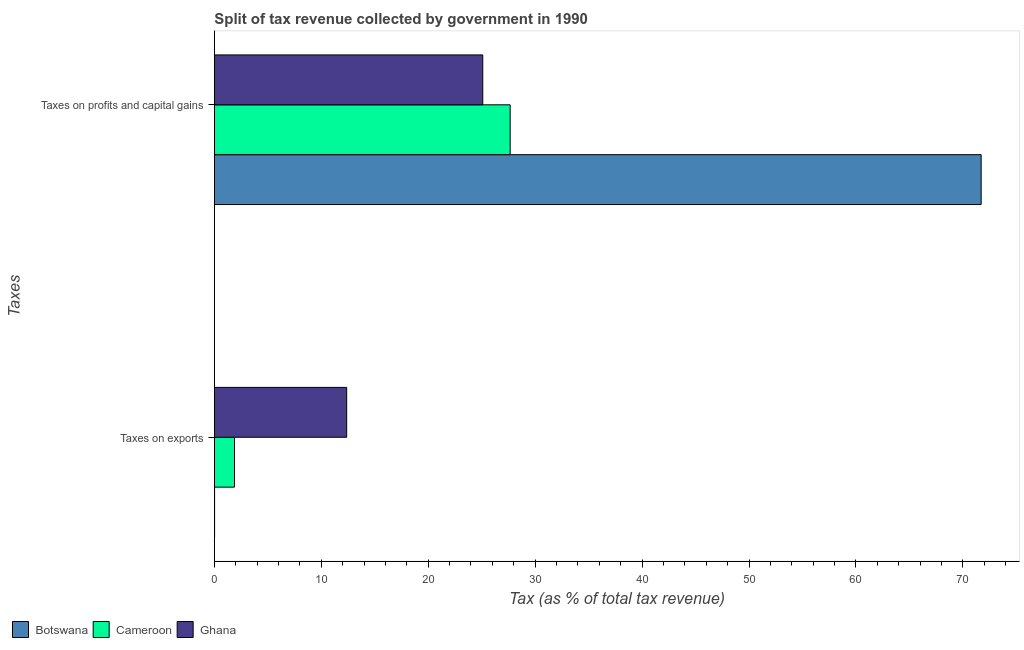Are the number of bars per tick equal to the number of legend labels?
Your answer should be very brief. Yes. Are the number of bars on each tick of the Y-axis equal?
Give a very brief answer. Yes. How many bars are there on the 1st tick from the top?
Keep it short and to the point. 3. How many bars are there on the 1st tick from the bottom?
Your response must be concise. 3. What is the label of the 2nd group of bars from the top?
Ensure brevity in your answer.  Taxes on exports. What is the percentage of revenue obtained from taxes on exports in Botswana?
Ensure brevity in your answer.  0.02. Across all countries, what is the maximum percentage of revenue obtained from taxes on profits and capital gains?
Provide a succinct answer. 71.71. Across all countries, what is the minimum percentage of revenue obtained from taxes on exports?
Provide a short and direct response. 0.02. In which country was the percentage of revenue obtained from taxes on exports maximum?
Give a very brief answer. Ghana. In which country was the percentage of revenue obtained from taxes on exports minimum?
Ensure brevity in your answer.  Botswana. What is the total percentage of revenue obtained from taxes on exports in the graph?
Your response must be concise. 14.28. What is the difference between the percentage of revenue obtained from taxes on exports in Ghana and that in Botswana?
Make the answer very short. 12.35. What is the difference between the percentage of revenue obtained from taxes on profits and capital gains in Ghana and the percentage of revenue obtained from taxes on exports in Botswana?
Your answer should be compact. 25.08. What is the average percentage of revenue obtained from taxes on exports per country?
Give a very brief answer. 4.76. What is the difference between the percentage of revenue obtained from taxes on exports and percentage of revenue obtained from taxes on profits and capital gains in Ghana?
Make the answer very short. -12.73. In how many countries, is the percentage of revenue obtained from taxes on exports greater than 66 %?
Provide a short and direct response. 0. What is the ratio of the percentage of revenue obtained from taxes on profits and capital gains in Cameroon to that in Botswana?
Offer a very short reply. 0.39. What does the 1st bar from the top in Taxes on exports represents?
Keep it short and to the point. Ghana. What does the 2nd bar from the bottom in Taxes on exports represents?
Give a very brief answer. Cameroon. How many bars are there?
Offer a terse response. 6. Are all the bars in the graph horizontal?
Give a very brief answer. Yes. How many countries are there in the graph?
Offer a very short reply. 3. Does the graph contain grids?
Make the answer very short. No. What is the title of the graph?
Offer a very short reply. Split of tax revenue collected by government in 1990. Does "Georgia" appear as one of the legend labels in the graph?
Your answer should be compact. No. What is the label or title of the X-axis?
Make the answer very short. Tax (as % of total tax revenue). What is the label or title of the Y-axis?
Provide a short and direct response. Taxes. What is the Tax (as % of total tax revenue) of Botswana in Taxes on exports?
Offer a very short reply. 0.02. What is the Tax (as % of total tax revenue) in Cameroon in Taxes on exports?
Keep it short and to the point. 1.89. What is the Tax (as % of total tax revenue) in Ghana in Taxes on exports?
Give a very brief answer. 12.37. What is the Tax (as % of total tax revenue) of Botswana in Taxes on profits and capital gains?
Offer a terse response. 71.71. What is the Tax (as % of total tax revenue) in Cameroon in Taxes on profits and capital gains?
Offer a very short reply. 27.66. What is the Tax (as % of total tax revenue) of Ghana in Taxes on profits and capital gains?
Offer a very short reply. 25.1. Across all Taxes, what is the maximum Tax (as % of total tax revenue) in Botswana?
Keep it short and to the point. 71.71. Across all Taxes, what is the maximum Tax (as % of total tax revenue) in Cameroon?
Offer a terse response. 27.66. Across all Taxes, what is the maximum Tax (as % of total tax revenue) of Ghana?
Your response must be concise. 25.1. Across all Taxes, what is the minimum Tax (as % of total tax revenue) in Botswana?
Make the answer very short. 0.02. Across all Taxes, what is the minimum Tax (as % of total tax revenue) of Cameroon?
Your response must be concise. 1.89. Across all Taxes, what is the minimum Tax (as % of total tax revenue) of Ghana?
Provide a short and direct response. 12.37. What is the total Tax (as % of total tax revenue) of Botswana in the graph?
Offer a terse response. 71.73. What is the total Tax (as % of total tax revenue) of Cameroon in the graph?
Provide a succinct answer. 29.55. What is the total Tax (as % of total tax revenue) in Ghana in the graph?
Make the answer very short. 37.48. What is the difference between the Tax (as % of total tax revenue) in Botswana in Taxes on exports and that in Taxes on profits and capital gains?
Make the answer very short. -71.69. What is the difference between the Tax (as % of total tax revenue) of Cameroon in Taxes on exports and that in Taxes on profits and capital gains?
Provide a short and direct response. -25.78. What is the difference between the Tax (as % of total tax revenue) in Ghana in Taxes on exports and that in Taxes on profits and capital gains?
Make the answer very short. -12.73. What is the difference between the Tax (as % of total tax revenue) of Botswana in Taxes on exports and the Tax (as % of total tax revenue) of Cameroon in Taxes on profits and capital gains?
Your response must be concise. -27.64. What is the difference between the Tax (as % of total tax revenue) in Botswana in Taxes on exports and the Tax (as % of total tax revenue) in Ghana in Taxes on profits and capital gains?
Your answer should be very brief. -25.08. What is the difference between the Tax (as % of total tax revenue) of Cameroon in Taxes on exports and the Tax (as % of total tax revenue) of Ghana in Taxes on profits and capital gains?
Your answer should be compact. -23.21. What is the average Tax (as % of total tax revenue) in Botswana per Taxes?
Provide a succinct answer. 35.87. What is the average Tax (as % of total tax revenue) of Cameroon per Taxes?
Provide a short and direct response. 14.77. What is the average Tax (as % of total tax revenue) of Ghana per Taxes?
Your answer should be very brief. 18.74. What is the difference between the Tax (as % of total tax revenue) in Botswana and Tax (as % of total tax revenue) in Cameroon in Taxes on exports?
Make the answer very short. -1.86. What is the difference between the Tax (as % of total tax revenue) in Botswana and Tax (as % of total tax revenue) in Ghana in Taxes on exports?
Provide a succinct answer. -12.35. What is the difference between the Tax (as % of total tax revenue) of Cameroon and Tax (as % of total tax revenue) of Ghana in Taxes on exports?
Provide a succinct answer. -10.49. What is the difference between the Tax (as % of total tax revenue) in Botswana and Tax (as % of total tax revenue) in Cameroon in Taxes on profits and capital gains?
Make the answer very short. 44.05. What is the difference between the Tax (as % of total tax revenue) in Botswana and Tax (as % of total tax revenue) in Ghana in Taxes on profits and capital gains?
Provide a succinct answer. 46.61. What is the difference between the Tax (as % of total tax revenue) in Cameroon and Tax (as % of total tax revenue) in Ghana in Taxes on profits and capital gains?
Ensure brevity in your answer.  2.56. What is the ratio of the Tax (as % of total tax revenue) in Cameroon in Taxes on exports to that in Taxes on profits and capital gains?
Give a very brief answer. 0.07. What is the ratio of the Tax (as % of total tax revenue) in Ghana in Taxes on exports to that in Taxes on profits and capital gains?
Your answer should be very brief. 0.49. What is the difference between the highest and the second highest Tax (as % of total tax revenue) of Botswana?
Provide a short and direct response. 71.69. What is the difference between the highest and the second highest Tax (as % of total tax revenue) in Cameroon?
Your answer should be compact. 25.78. What is the difference between the highest and the second highest Tax (as % of total tax revenue) in Ghana?
Give a very brief answer. 12.73. What is the difference between the highest and the lowest Tax (as % of total tax revenue) in Botswana?
Make the answer very short. 71.69. What is the difference between the highest and the lowest Tax (as % of total tax revenue) in Cameroon?
Your answer should be very brief. 25.78. What is the difference between the highest and the lowest Tax (as % of total tax revenue) in Ghana?
Your response must be concise. 12.73. 